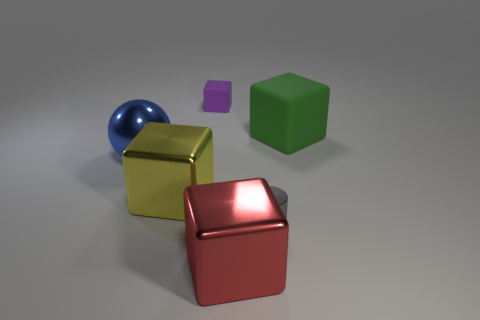Why might these objects be arranged in this manner? The arrangement of objects could be part of a visual composition study. It demonstrates how different shapes, sizes, and colors interact within a space, which can be useful for artists or designers in understanding spatial relationships and color theory. 